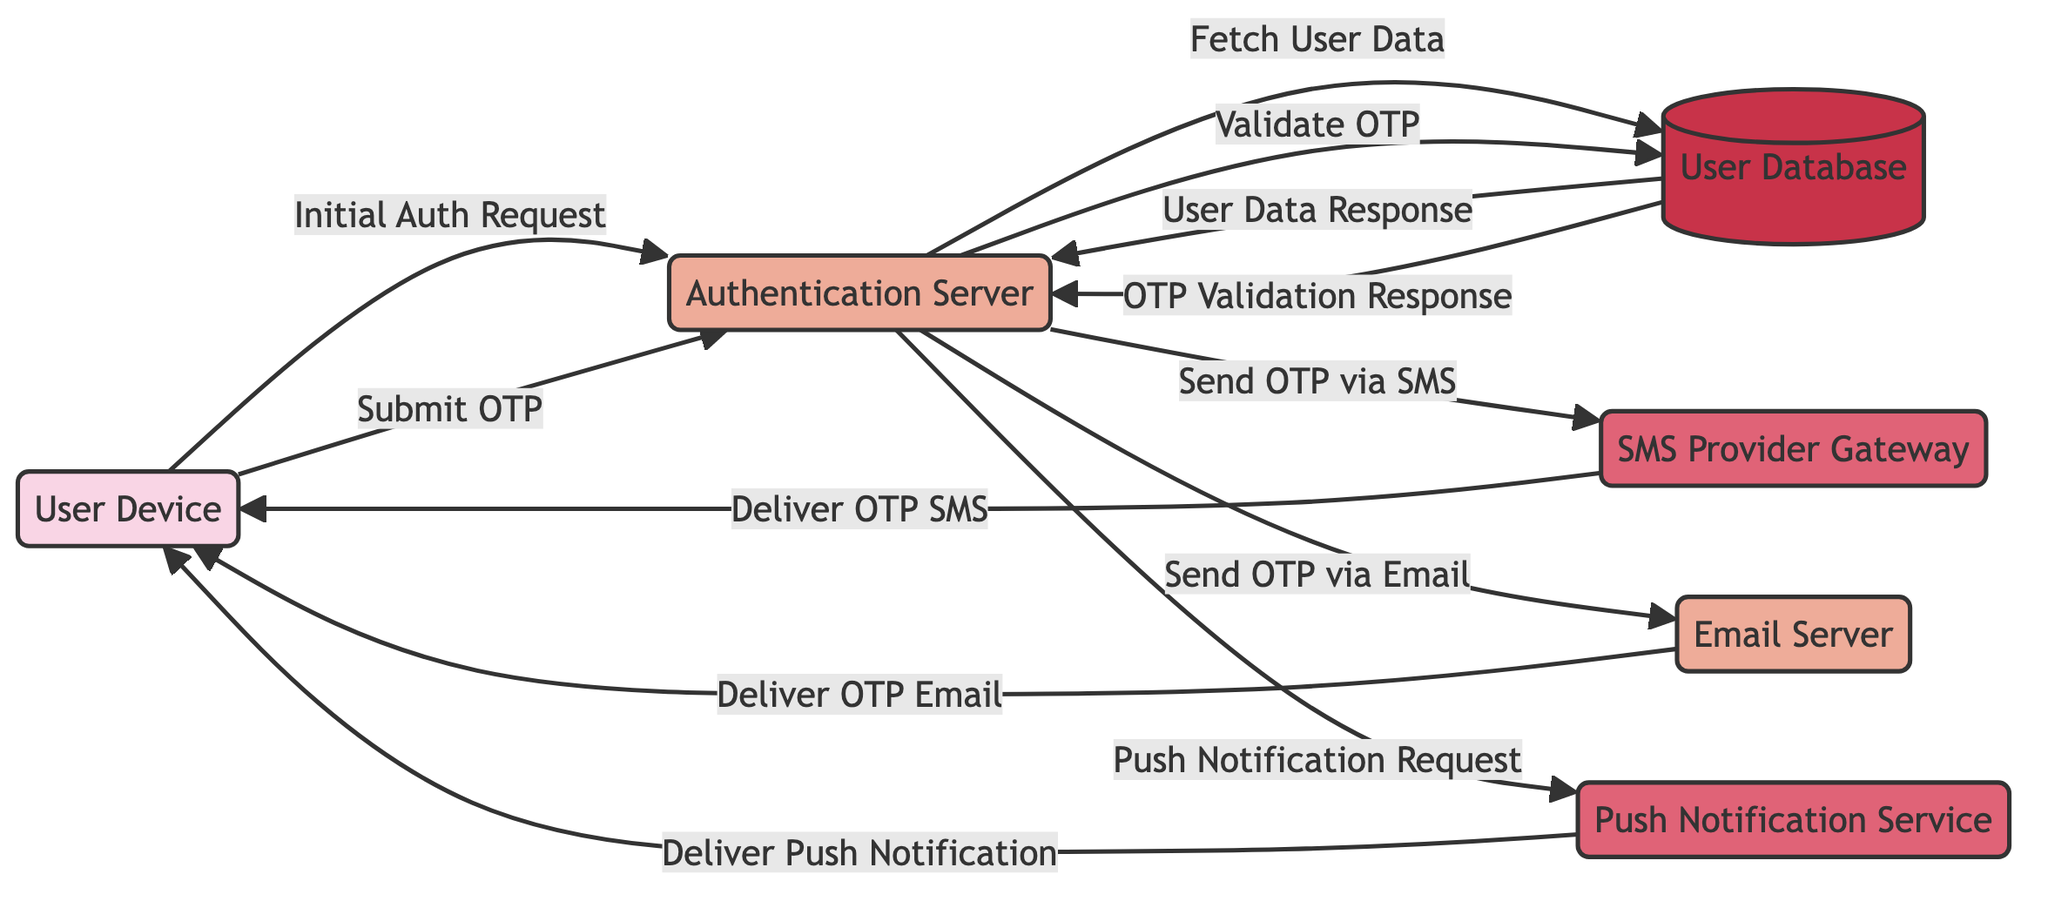What is the total number of nodes in the diagram? The diagram includes six distinct elements: User Device, Authentication Server, SMS Provider Gateway, Email Server, Push Notification Service, and User Database. Counting these nodes gives us a total of six nodes.
Answer: 6 What is the relationship label between the User Device and the Authentication Server? The edge directly connecting the User Device to the Authentication Server is labeled "Initial Auth Request," indicating this is the initial step in the communication pathway.
Answer: Initial Auth Request Which external services are involved in the authentication process? The external services shown in the diagram are the SMS Provider Gateway and the Push Notification Service. These services are essential for delivering OTPs to the user.
Answer: SMS Provider Gateway, Push Notification Service What type of request does the Authentication Server send to the Email Server? According to the diagram, the Authentication Server sends a "Send OTP via Email" request to the Email Server as part of the multi-factor authentication process.
Answer: Send OTP via Email How many requests are made by the Authentication Server throughout the flow? By tracing the edges connected to the Authentication Server in the diagram, we find that there are four requests: Initial Auth Request, Send OTP via SMS, Send OTP via Email, and Push Notification Request.
Answer: 4 Which service delivers OTP notifications to the User Device? The User Device receives OTP notifications from three different services: SMS Provider Gateway, Email Server, and Push Notification Service, each responsible for delivering different types of notifications.
Answer: SMS Provider Gateway, Email Server, Push Notification Service What data flow exists from the User Database to the Authentication Server? The User Database sends two flows of data back to the Authentication Server: one is the "User Data Response" after fetching user data, and the other is the "OTP Validation Response" after validating the OTP.
Answer: User Data Response, OTP Validation Response Which node is responsible for validating the OTP? The Authentication Server is responsible for validating the OTP, as indicated by the edge labeled "Validate OTP" pointing from the Authentication Server to the User Database.
Answer: Authentication Server What type of edge connects the SMS Provider to the User Device? The diagram indicates that the edge from SMS Provider to User Device is labeled "Deliver OTP SMS," characterizing it as a notification type of edge.
Answer: Deliver OTP SMS 